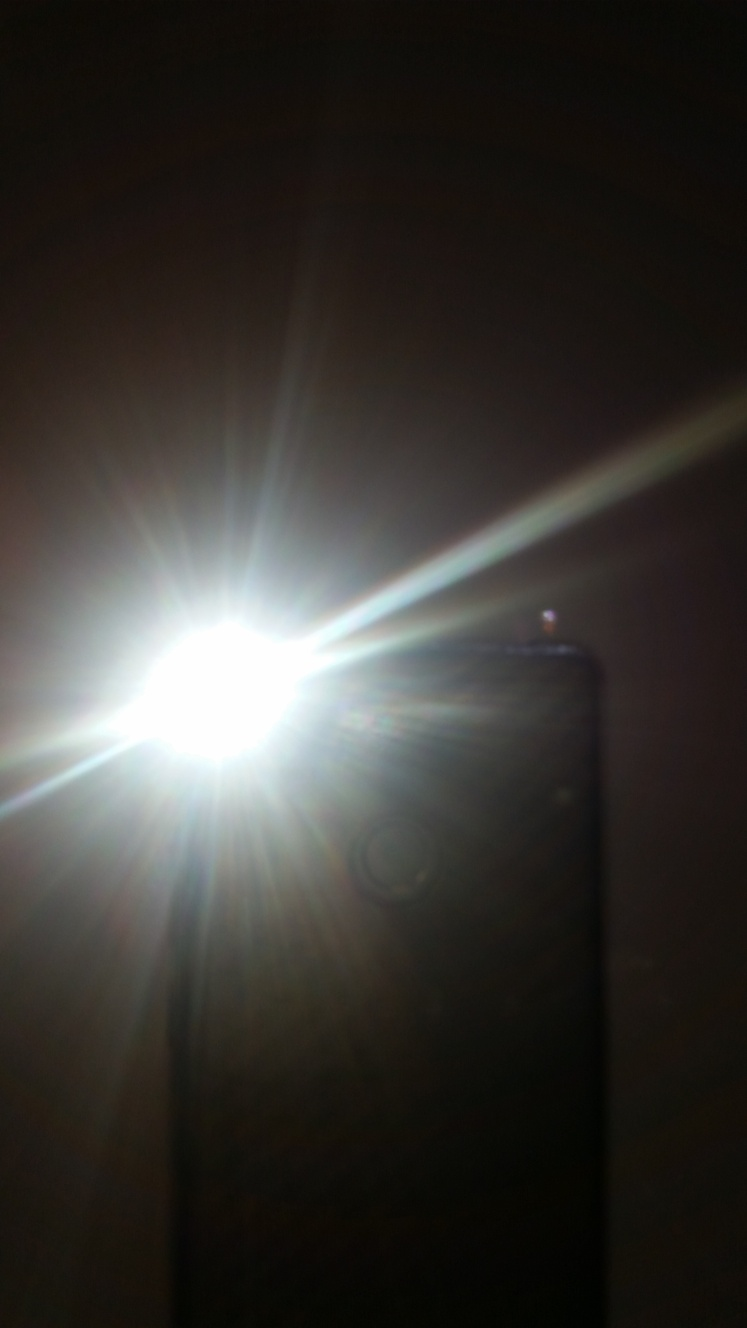What makes it difficult to discern the subject?
A. Good lighting
B. Severe overexposure
C. Sharp focus
D. Underexposure The subject in the image is difficult to discern primarily due to the issue of severe overexposure. The light source is overwhelmingly bright, causing the rest of the scene to be washed out and details to become obscure. Overexposure occurs when the amount of light entering the lens is too high for the camera's sensor, resulting in a loss of detail in the brightest parts of the photograph. 